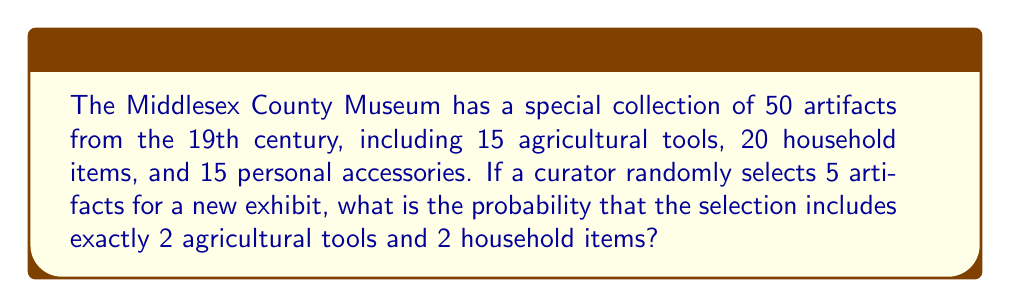Solve this math problem. Let's approach this step-by-step using the hypergeometric distribution:

1) We need to choose 2 agricultural tools, 2 household items, and 1 item from the remaining artifacts.

2) The number of ways to choose 2 agricultural tools out of 15:
   $${15 \choose 2} = \frac{15!}{2!(15-2)!} = 105$$

3) The number of ways to choose 2 household items out of 20:
   $${20 \choose 2} = \frac{20!}{2!(20-2)!} = 190$$

4) The number of ways to choose 1 item from the remaining 15 personal accessories:
   $${15 \choose 1} = 15$$

5) The total number of favorable outcomes is the product of these:
   $$105 \times 190 \times 15 = 299,250$$

6) The total number of ways to choose 5 items out of 50:
   $${50 \choose 5} = \frac{50!}{5!(50-5)!} = 2,118,760$$

7) The probability is the number of favorable outcomes divided by the total number of possible outcomes:

   $$P(\text{2 agricultural, 2 household, 1 other}) = \frac{299,250}{2,118,760} = \frac{29,925}{211,876} \approx 0.1412$$
Answer: $\frac{29,925}{211,876}$ 